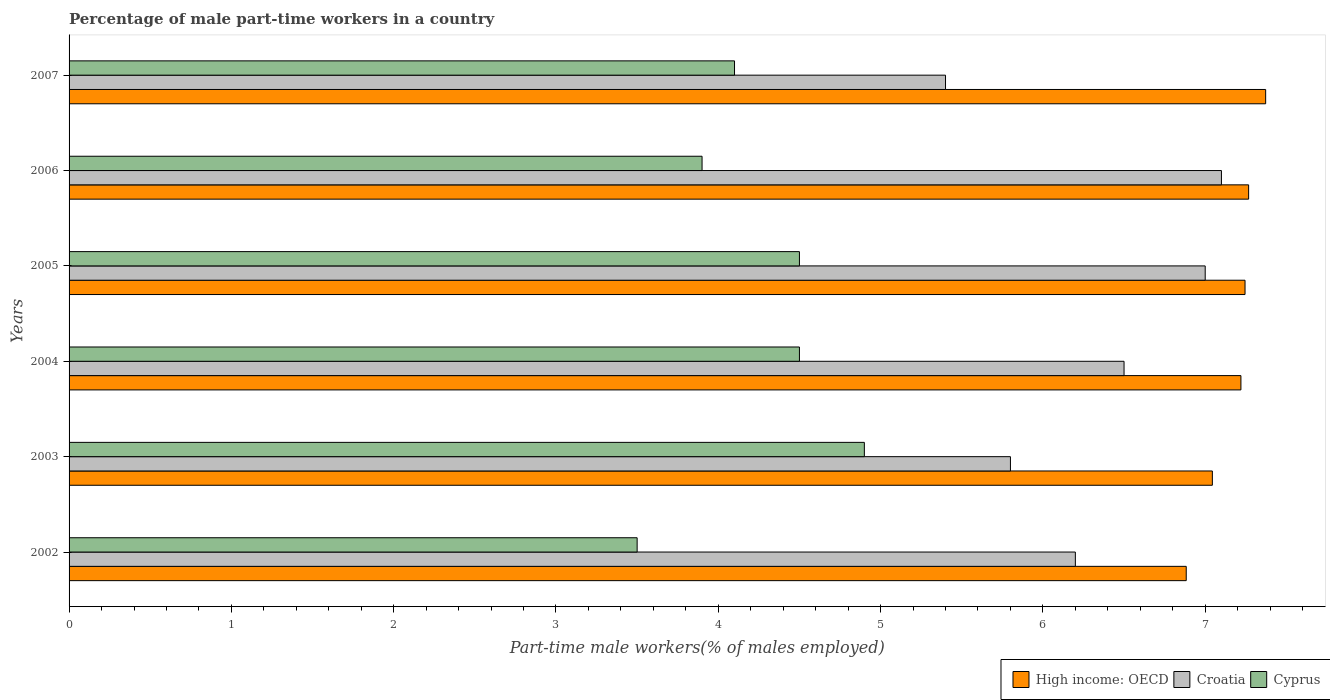Are the number of bars on each tick of the Y-axis equal?
Your response must be concise. Yes. How many bars are there on the 1st tick from the top?
Your answer should be very brief. 3. How many bars are there on the 6th tick from the bottom?
Ensure brevity in your answer.  3. What is the label of the 2nd group of bars from the top?
Keep it short and to the point. 2006. In how many cases, is the number of bars for a given year not equal to the number of legend labels?
Ensure brevity in your answer.  0. What is the percentage of male part-time workers in Croatia in 2007?
Your answer should be very brief. 5.4. Across all years, what is the maximum percentage of male part-time workers in High income: OECD?
Give a very brief answer. 7.37. Across all years, what is the minimum percentage of male part-time workers in High income: OECD?
Make the answer very short. 6.88. In which year was the percentage of male part-time workers in High income: OECD maximum?
Keep it short and to the point. 2007. In which year was the percentage of male part-time workers in High income: OECD minimum?
Your response must be concise. 2002. What is the total percentage of male part-time workers in High income: OECD in the graph?
Your answer should be compact. 43.03. What is the difference between the percentage of male part-time workers in High income: OECD in 2005 and that in 2007?
Ensure brevity in your answer.  -0.13. What is the difference between the percentage of male part-time workers in Cyprus in 2004 and the percentage of male part-time workers in High income: OECD in 2002?
Keep it short and to the point. -2.38. What is the average percentage of male part-time workers in High income: OECD per year?
Provide a short and direct response. 7.17. In the year 2006, what is the difference between the percentage of male part-time workers in Cyprus and percentage of male part-time workers in Croatia?
Your answer should be very brief. -3.2. In how many years, is the percentage of male part-time workers in High income: OECD greater than 7.2 %?
Provide a succinct answer. 4. What is the ratio of the percentage of male part-time workers in Croatia in 2006 to that in 2007?
Your answer should be compact. 1.31. Is the percentage of male part-time workers in High income: OECD in 2002 less than that in 2007?
Offer a terse response. Yes. Is the difference between the percentage of male part-time workers in Cyprus in 2002 and 2006 greater than the difference between the percentage of male part-time workers in Croatia in 2002 and 2006?
Keep it short and to the point. Yes. What is the difference between the highest and the second highest percentage of male part-time workers in High income: OECD?
Keep it short and to the point. 0.11. What is the difference between the highest and the lowest percentage of male part-time workers in Cyprus?
Offer a terse response. 1.4. What does the 1st bar from the top in 2006 represents?
Offer a very short reply. Cyprus. What does the 2nd bar from the bottom in 2002 represents?
Offer a very short reply. Croatia. How many bars are there?
Your response must be concise. 18. Are all the bars in the graph horizontal?
Your answer should be compact. Yes. What is the difference between two consecutive major ticks on the X-axis?
Offer a terse response. 1. Are the values on the major ticks of X-axis written in scientific E-notation?
Offer a terse response. No. Does the graph contain any zero values?
Provide a short and direct response. No. Does the graph contain grids?
Provide a short and direct response. No. Where does the legend appear in the graph?
Give a very brief answer. Bottom right. How many legend labels are there?
Provide a short and direct response. 3. What is the title of the graph?
Make the answer very short. Percentage of male part-time workers in a country. Does "Cameroon" appear as one of the legend labels in the graph?
Your answer should be compact. No. What is the label or title of the X-axis?
Offer a terse response. Part-time male workers(% of males employed). What is the Part-time male workers(% of males employed) of High income: OECD in 2002?
Offer a very short reply. 6.88. What is the Part-time male workers(% of males employed) in Croatia in 2002?
Make the answer very short. 6.2. What is the Part-time male workers(% of males employed) of High income: OECD in 2003?
Make the answer very short. 7.04. What is the Part-time male workers(% of males employed) in Croatia in 2003?
Ensure brevity in your answer.  5.8. What is the Part-time male workers(% of males employed) in Cyprus in 2003?
Your answer should be very brief. 4.9. What is the Part-time male workers(% of males employed) of High income: OECD in 2004?
Make the answer very short. 7.22. What is the Part-time male workers(% of males employed) in Croatia in 2004?
Ensure brevity in your answer.  6.5. What is the Part-time male workers(% of males employed) of Cyprus in 2004?
Give a very brief answer. 4.5. What is the Part-time male workers(% of males employed) of High income: OECD in 2005?
Offer a very short reply. 7.25. What is the Part-time male workers(% of males employed) of Croatia in 2005?
Your response must be concise. 7. What is the Part-time male workers(% of males employed) in High income: OECD in 2006?
Your answer should be very brief. 7.27. What is the Part-time male workers(% of males employed) of Croatia in 2006?
Provide a succinct answer. 7.1. What is the Part-time male workers(% of males employed) in Cyprus in 2006?
Ensure brevity in your answer.  3.9. What is the Part-time male workers(% of males employed) in High income: OECD in 2007?
Give a very brief answer. 7.37. What is the Part-time male workers(% of males employed) in Croatia in 2007?
Keep it short and to the point. 5.4. What is the Part-time male workers(% of males employed) in Cyprus in 2007?
Keep it short and to the point. 4.1. Across all years, what is the maximum Part-time male workers(% of males employed) of High income: OECD?
Your answer should be compact. 7.37. Across all years, what is the maximum Part-time male workers(% of males employed) of Croatia?
Your answer should be compact. 7.1. Across all years, what is the maximum Part-time male workers(% of males employed) of Cyprus?
Keep it short and to the point. 4.9. Across all years, what is the minimum Part-time male workers(% of males employed) in High income: OECD?
Provide a succinct answer. 6.88. Across all years, what is the minimum Part-time male workers(% of males employed) in Croatia?
Keep it short and to the point. 5.4. What is the total Part-time male workers(% of males employed) of High income: OECD in the graph?
Your answer should be very brief. 43.03. What is the total Part-time male workers(% of males employed) of Cyprus in the graph?
Your answer should be very brief. 25.4. What is the difference between the Part-time male workers(% of males employed) of High income: OECD in 2002 and that in 2003?
Offer a very short reply. -0.16. What is the difference between the Part-time male workers(% of males employed) in High income: OECD in 2002 and that in 2004?
Provide a succinct answer. -0.34. What is the difference between the Part-time male workers(% of males employed) of Croatia in 2002 and that in 2004?
Your answer should be compact. -0.3. What is the difference between the Part-time male workers(% of males employed) of Cyprus in 2002 and that in 2004?
Your response must be concise. -1. What is the difference between the Part-time male workers(% of males employed) of High income: OECD in 2002 and that in 2005?
Ensure brevity in your answer.  -0.36. What is the difference between the Part-time male workers(% of males employed) in Croatia in 2002 and that in 2005?
Your answer should be compact. -0.8. What is the difference between the Part-time male workers(% of males employed) of Cyprus in 2002 and that in 2005?
Your answer should be very brief. -1. What is the difference between the Part-time male workers(% of males employed) in High income: OECD in 2002 and that in 2006?
Your response must be concise. -0.38. What is the difference between the Part-time male workers(% of males employed) of Croatia in 2002 and that in 2006?
Ensure brevity in your answer.  -0.9. What is the difference between the Part-time male workers(% of males employed) of Cyprus in 2002 and that in 2006?
Keep it short and to the point. -0.4. What is the difference between the Part-time male workers(% of males employed) in High income: OECD in 2002 and that in 2007?
Offer a very short reply. -0.49. What is the difference between the Part-time male workers(% of males employed) in Croatia in 2002 and that in 2007?
Offer a terse response. 0.8. What is the difference between the Part-time male workers(% of males employed) of High income: OECD in 2003 and that in 2004?
Provide a short and direct response. -0.18. What is the difference between the Part-time male workers(% of males employed) in Cyprus in 2003 and that in 2004?
Keep it short and to the point. 0.4. What is the difference between the Part-time male workers(% of males employed) of High income: OECD in 2003 and that in 2005?
Offer a terse response. -0.2. What is the difference between the Part-time male workers(% of males employed) of Croatia in 2003 and that in 2005?
Provide a succinct answer. -1.2. What is the difference between the Part-time male workers(% of males employed) of High income: OECD in 2003 and that in 2006?
Offer a very short reply. -0.22. What is the difference between the Part-time male workers(% of males employed) of High income: OECD in 2003 and that in 2007?
Offer a terse response. -0.33. What is the difference between the Part-time male workers(% of males employed) of Cyprus in 2003 and that in 2007?
Make the answer very short. 0.8. What is the difference between the Part-time male workers(% of males employed) in High income: OECD in 2004 and that in 2005?
Ensure brevity in your answer.  -0.03. What is the difference between the Part-time male workers(% of males employed) of High income: OECD in 2004 and that in 2006?
Provide a succinct answer. -0.05. What is the difference between the Part-time male workers(% of males employed) in Croatia in 2004 and that in 2006?
Ensure brevity in your answer.  -0.6. What is the difference between the Part-time male workers(% of males employed) in Cyprus in 2004 and that in 2006?
Your answer should be very brief. 0.6. What is the difference between the Part-time male workers(% of males employed) of High income: OECD in 2004 and that in 2007?
Offer a terse response. -0.15. What is the difference between the Part-time male workers(% of males employed) in High income: OECD in 2005 and that in 2006?
Give a very brief answer. -0.02. What is the difference between the Part-time male workers(% of males employed) of Cyprus in 2005 and that in 2006?
Your answer should be compact. 0.6. What is the difference between the Part-time male workers(% of males employed) of High income: OECD in 2005 and that in 2007?
Your answer should be compact. -0.13. What is the difference between the Part-time male workers(% of males employed) in High income: OECD in 2006 and that in 2007?
Make the answer very short. -0.1. What is the difference between the Part-time male workers(% of males employed) of Croatia in 2006 and that in 2007?
Your response must be concise. 1.7. What is the difference between the Part-time male workers(% of males employed) of Cyprus in 2006 and that in 2007?
Ensure brevity in your answer.  -0.2. What is the difference between the Part-time male workers(% of males employed) of High income: OECD in 2002 and the Part-time male workers(% of males employed) of Croatia in 2003?
Your response must be concise. 1.08. What is the difference between the Part-time male workers(% of males employed) of High income: OECD in 2002 and the Part-time male workers(% of males employed) of Cyprus in 2003?
Your answer should be very brief. 1.98. What is the difference between the Part-time male workers(% of males employed) in Croatia in 2002 and the Part-time male workers(% of males employed) in Cyprus in 2003?
Offer a terse response. 1.3. What is the difference between the Part-time male workers(% of males employed) in High income: OECD in 2002 and the Part-time male workers(% of males employed) in Croatia in 2004?
Your answer should be compact. 0.38. What is the difference between the Part-time male workers(% of males employed) of High income: OECD in 2002 and the Part-time male workers(% of males employed) of Cyprus in 2004?
Give a very brief answer. 2.38. What is the difference between the Part-time male workers(% of males employed) in Croatia in 2002 and the Part-time male workers(% of males employed) in Cyprus in 2004?
Provide a short and direct response. 1.7. What is the difference between the Part-time male workers(% of males employed) of High income: OECD in 2002 and the Part-time male workers(% of males employed) of Croatia in 2005?
Your response must be concise. -0.12. What is the difference between the Part-time male workers(% of males employed) of High income: OECD in 2002 and the Part-time male workers(% of males employed) of Cyprus in 2005?
Offer a terse response. 2.38. What is the difference between the Part-time male workers(% of males employed) of High income: OECD in 2002 and the Part-time male workers(% of males employed) of Croatia in 2006?
Make the answer very short. -0.22. What is the difference between the Part-time male workers(% of males employed) in High income: OECD in 2002 and the Part-time male workers(% of males employed) in Cyprus in 2006?
Give a very brief answer. 2.98. What is the difference between the Part-time male workers(% of males employed) in High income: OECD in 2002 and the Part-time male workers(% of males employed) in Croatia in 2007?
Your answer should be very brief. 1.48. What is the difference between the Part-time male workers(% of males employed) of High income: OECD in 2002 and the Part-time male workers(% of males employed) of Cyprus in 2007?
Ensure brevity in your answer.  2.78. What is the difference between the Part-time male workers(% of males employed) of High income: OECD in 2003 and the Part-time male workers(% of males employed) of Croatia in 2004?
Ensure brevity in your answer.  0.54. What is the difference between the Part-time male workers(% of males employed) in High income: OECD in 2003 and the Part-time male workers(% of males employed) in Cyprus in 2004?
Give a very brief answer. 2.54. What is the difference between the Part-time male workers(% of males employed) of Croatia in 2003 and the Part-time male workers(% of males employed) of Cyprus in 2004?
Keep it short and to the point. 1.3. What is the difference between the Part-time male workers(% of males employed) of High income: OECD in 2003 and the Part-time male workers(% of males employed) of Croatia in 2005?
Make the answer very short. 0.04. What is the difference between the Part-time male workers(% of males employed) in High income: OECD in 2003 and the Part-time male workers(% of males employed) in Cyprus in 2005?
Make the answer very short. 2.54. What is the difference between the Part-time male workers(% of males employed) in Croatia in 2003 and the Part-time male workers(% of males employed) in Cyprus in 2005?
Provide a succinct answer. 1.3. What is the difference between the Part-time male workers(% of males employed) in High income: OECD in 2003 and the Part-time male workers(% of males employed) in Croatia in 2006?
Ensure brevity in your answer.  -0.06. What is the difference between the Part-time male workers(% of males employed) of High income: OECD in 2003 and the Part-time male workers(% of males employed) of Cyprus in 2006?
Provide a short and direct response. 3.14. What is the difference between the Part-time male workers(% of males employed) of High income: OECD in 2003 and the Part-time male workers(% of males employed) of Croatia in 2007?
Keep it short and to the point. 1.64. What is the difference between the Part-time male workers(% of males employed) of High income: OECD in 2003 and the Part-time male workers(% of males employed) of Cyprus in 2007?
Provide a short and direct response. 2.94. What is the difference between the Part-time male workers(% of males employed) in Croatia in 2003 and the Part-time male workers(% of males employed) in Cyprus in 2007?
Make the answer very short. 1.7. What is the difference between the Part-time male workers(% of males employed) of High income: OECD in 2004 and the Part-time male workers(% of males employed) of Croatia in 2005?
Make the answer very short. 0.22. What is the difference between the Part-time male workers(% of males employed) of High income: OECD in 2004 and the Part-time male workers(% of males employed) of Cyprus in 2005?
Give a very brief answer. 2.72. What is the difference between the Part-time male workers(% of males employed) of High income: OECD in 2004 and the Part-time male workers(% of males employed) of Croatia in 2006?
Offer a very short reply. 0.12. What is the difference between the Part-time male workers(% of males employed) in High income: OECD in 2004 and the Part-time male workers(% of males employed) in Cyprus in 2006?
Your response must be concise. 3.32. What is the difference between the Part-time male workers(% of males employed) of Croatia in 2004 and the Part-time male workers(% of males employed) of Cyprus in 2006?
Your answer should be compact. 2.6. What is the difference between the Part-time male workers(% of males employed) of High income: OECD in 2004 and the Part-time male workers(% of males employed) of Croatia in 2007?
Your answer should be compact. 1.82. What is the difference between the Part-time male workers(% of males employed) in High income: OECD in 2004 and the Part-time male workers(% of males employed) in Cyprus in 2007?
Your response must be concise. 3.12. What is the difference between the Part-time male workers(% of males employed) in Croatia in 2004 and the Part-time male workers(% of males employed) in Cyprus in 2007?
Make the answer very short. 2.4. What is the difference between the Part-time male workers(% of males employed) of High income: OECD in 2005 and the Part-time male workers(% of males employed) of Croatia in 2006?
Your answer should be very brief. 0.15. What is the difference between the Part-time male workers(% of males employed) of High income: OECD in 2005 and the Part-time male workers(% of males employed) of Cyprus in 2006?
Your answer should be very brief. 3.35. What is the difference between the Part-time male workers(% of males employed) in Croatia in 2005 and the Part-time male workers(% of males employed) in Cyprus in 2006?
Give a very brief answer. 3.1. What is the difference between the Part-time male workers(% of males employed) of High income: OECD in 2005 and the Part-time male workers(% of males employed) of Croatia in 2007?
Your answer should be compact. 1.85. What is the difference between the Part-time male workers(% of males employed) of High income: OECD in 2005 and the Part-time male workers(% of males employed) of Cyprus in 2007?
Make the answer very short. 3.15. What is the difference between the Part-time male workers(% of males employed) of High income: OECD in 2006 and the Part-time male workers(% of males employed) of Croatia in 2007?
Provide a succinct answer. 1.87. What is the difference between the Part-time male workers(% of males employed) in High income: OECD in 2006 and the Part-time male workers(% of males employed) in Cyprus in 2007?
Give a very brief answer. 3.17. What is the average Part-time male workers(% of males employed) in High income: OECD per year?
Your answer should be very brief. 7.17. What is the average Part-time male workers(% of males employed) in Croatia per year?
Provide a short and direct response. 6.33. What is the average Part-time male workers(% of males employed) in Cyprus per year?
Your answer should be compact. 4.23. In the year 2002, what is the difference between the Part-time male workers(% of males employed) of High income: OECD and Part-time male workers(% of males employed) of Croatia?
Make the answer very short. 0.68. In the year 2002, what is the difference between the Part-time male workers(% of males employed) in High income: OECD and Part-time male workers(% of males employed) in Cyprus?
Keep it short and to the point. 3.38. In the year 2003, what is the difference between the Part-time male workers(% of males employed) of High income: OECD and Part-time male workers(% of males employed) of Croatia?
Your answer should be compact. 1.24. In the year 2003, what is the difference between the Part-time male workers(% of males employed) of High income: OECD and Part-time male workers(% of males employed) of Cyprus?
Provide a succinct answer. 2.14. In the year 2003, what is the difference between the Part-time male workers(% of males employed) of Croatia and Part-time male workers(% of males employed) of Cyprus?
Your answer should be very brief. 0.9. In the year 2004, what is the difference between the Part-time male workers(% of males employed) in High income: OECD and Part-time male workers(% of males employed) in Croatia?
Keep it short and to the point. 0.72. In the year 2004, what is the difference between the Part-time male workers(% of males employed) in High income: OECD and Part-time male workers(% of males employed) in Cyprus?
Your response must be concise. 2.72. In the year 2005, what is the difference between the Part-time male workers(% of males employed) in High income: OECD and Part-time male workers(% of males employed) in Croatia?
Give a very brief answer. 0.25. In the year 2005, what is the difference between the Part-time male workers(% of males employed) of High income: OECD and Part-time male workers(% of males employed) of Cyprus?
Your answer should be compact. 2.75. In the year 2006, what is the difference between the Part-time male workers(% of males employed) in High income: OECD and Part-time male workers(% of males employed) in Croatia?
Provide a succinct answer. 0.17. In the year 2006, what is the difference between the Part-time male workers(% of males employed) in High income: OECD and Part-time male workers(% of males employed) in Cyprus?
Your answer should be compact. 3.37. In the year 2006, what is the difference between the Part-time male workers(% of males employed) of Croatia and Part-time male workers(% of males employed) of Cyprus?
Your answer should be very brief. 3.2. In the year 2007, what is the difference between the Part-time male workers(% of males employed) in High income: OECD and Part-time male workers(% of males employed) in Croatia?
Keep it short and to the point. 1.97. In the year 2007, what is the difference between the Part-time male workers(% of males employed) in High income: OECD and Part-time male workers(% of males employed) in Cyprus?
Your answer should be compact. 3.27. What is the ratio of the Part-time male workers(% of males employed) in High income: OECD in 2002 to that in 2003?
Give a very brief answer. 0.98. What is the ratio of the Part-time male workers(% of males employed) in Croatia in 2002 to that in 2003?
Your answer should be compact. 1.07. What is the ratio of the Part-time male workers(% of males employed) in High income: OECD in 2002 to that in 2004?
Ensure brevity in your answer.  0.95. What is the ratio of the Part-time male workers(% of males employed) of Croatia in 2002 to that in 2004?
Offer a very short reply. 0.95. What is the ratio of the Part-time male workers(% of males employed) in High income: OECD in 2002 to that in 2005?
Your response must be concise. 0.95. What is the ratio of the Part-time male workers(% of males employed) in Croatia in 2002 to that in 2005?
Your answer should be very brief. 0.89. What is the ratio of the Part-time male workers(% of males employed) in Cyprus in 2002 to that in 2005?
Provide a short and direct response. 0.78. What is the ratio of the Part-time male workers(% of males employed) of High income: OECD in 2002 to that in 2006?
Your answer should be very brief. 0.95. What is the ratio of the Part-time male workers(% of males employed) in Croatia in 2002 to that in 2006?
Your response must be concise. 0.87. What is the ratio of the Part-time male workers(% of males employed) of Cyprus in 2002 to that in 2006?
Ensure brevity in your answer.  0.9. What is the ratio of the Part-time male workers(% of males employed) of High income: OECD in 2002 to that in 2007?
Offer a very short reply. 0.93. What is the ratio of the Part-time male workers(% of males employed) in Croatia in 2002 to that in 2007?
Your answer should be compact. 1.15. What is the ratio of the Part-time male workers(% of males employed) of Cyprus in 2002 to that in 2007?
Provide a succinct answer. 0.85. What is the ratio of the Part-time male workers(% of males employed) of High income: OECD in 2003 to that in 2004?
Offer a terse response. 0.98. What is the ratio of the Part-time male workers(% of males employed) of Croatia in 2003 to that in 2004?
Give a very brief answer. 0.89. What is the ratio of the Part-time male workers(% of males employed) in Cyprus in 2003 to that in 2004?
Your answer should be very brief. 1.09. What is the ratio of the Part-time male workers(% of males employed) in High income: OECD in 2003 to that in 2005?
Provide a short and direct response. 0.97. What is the ratio of the Part-time male workers(% of males employed) of Croatia in 2003 to that in 2005?
Provide a succinct answer. 0.83. What is the ratio of the Part-time male workers(% of males employed) in Cyprus in 2003 to that in 2005?
Ensure brevity in your answer.  1.09. What is the ratio of the Part-time male workers(% of males employed) in High income: OECD in 2003 to that in 2006?
Your response must be concise. 0.97. What is the ratio of the Part-time male workers(% of males employed) in Croatia in 2003 to that in 2006?
Provide a succinct answer. 0.82. What is the ratio of the Part-time male workers(% of males employed) of Cyprus in 2003 to that in 2006?
Provide a short and direct response. 1.26. What is the ratio of the Part-time male workers(% of males employed) in High income: OECD in 2003 to that in 2007?
Your answer should be compact. 0.96. What is the ratio of the Part-time male workers(% of males employed) of Croatia in 2003 to that in 2007?
Give a very brief answer. 1.07. What is the ratio of the Part-time male workers(% of males employed) in Cyprus in 2003 to that in 2007?
Your answer should be compact. 1.2. What is the ratio of the Part-time male workers(% of males employed) of High income: OECD in 2004 to that in 2005?
Provide a succinct answer. 1. What is the ratio of the Part-time male workers(% of males employed) in Croatia in 2004 to that in 2005?
Offer a very short reply. 0.93. What is the ratio of the Part-time male workers(% of males employed) of Croatia in 2004 to that in 2006?
Offer a terse response. 0.92. What is the ratio of the Part-time male workers(% of males employed) in Cyprus in 2004 to that in 2006?
Make the answer very short. 1.15. What is the ratio of the Part-time male workers(% of males employed) of High income: OECD in 2004 to that in 2007?
Keep it short and to the point. 0.98. What is the ratio of the Part-time male workers(% of males employed) of Croatia in 2004 to that in 2007?
Keep it short and to the point. 1.2. What is the ratio of the Part-time male workers(% of males employed) in Cyprus in 2004 to that in 2007?
Give a very brief answer. 1.1. What is the ratio of the Part-time male workers(% of males employed) in Croatia in 2005 to that in 2006?
Provide a succinct answer. 0.99. What is the ratio of the Part-time male workers(% of males employed) in Cyprus in 2005 to that in 2006?
Offer a terse response. 1.15. What is the ratio of the Part-time male workers(% of males employed) in High income: OECD in 2005 to that in 2007?
Provide a short and direct response. 0.98. What is the ratio of the Part-time male workers(% of males employed) of Croatia in 2005 to that in 2007?
Your answer should be compact. 1.3. What is the ratio of the Part-time male workers(% of males employed) of Cyprus in 2005 to that in 2007?
Your answer should be compact. 1.1. What is the ratio of the Part-time male workers(% of males employed) in High income: OECD in 2006 to that in 2007?
Your response must be concise. 0.99. What is the ratio of the Part-time male workers(% of males employed) in Croatia in 2006 to that in 2007?
Ensure brevity in your answer.  1.31. What is the ratio of the Part-time male workers(% of males employed) in Cyprus in 2006 to that in 2007?
Give a very brief answer. 0.95. What is the difference between the highest and the second highest Part-time male workers(% of males employed) of High income: OECD?
Make the answer very short. 0.1. What is the difference between the highest and the second highest Part-time male workers(% of males employed) of Cyprus?
Your answer should be very brief. 0.4. What is the difference between the highest and the lowest Part-time male workers(% of males employed) of High income: OECD?
Provide a succinct answer. 0.49. What is the difference between the highest and the lowest Part-time male workers(% of males employed) in Cyprus?
Keep it short and to the point. 1.4. 